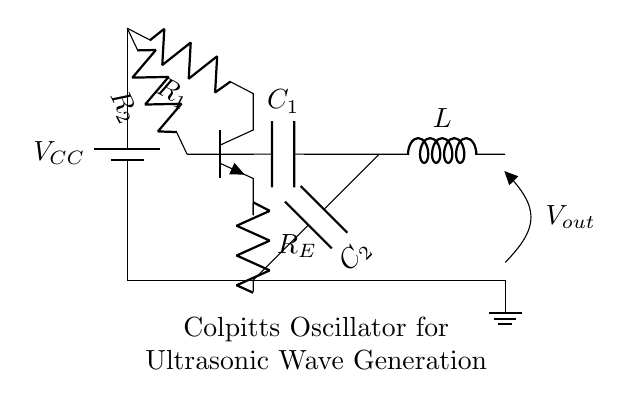What type of oscillator is depicted in the circuit? The circuit diagram specifically illustrates a Colpitts oscillator, which is characterized by its use of capacitors and inductors to form the feedback necessary for oscillation.
Answer: Colpitts oscillator What is the value of resistor R1? The circuit diagram does not specify the numerical values of component R1, but it is labeled to indicate its position and purpose within the circuit.
Answer: Not specified What components are used in this Colpitts oscillator? The essential components are a transistor, two capacitors (C1 and C2), an inductor (L), and three resistors (R1, R2, and RE), collectively facilitating oscillation.
Answer: Transistor, capacitors, inductor, resistors Where is the output voltage taken from in this circuit? The output voltage is taken across the inductor, as indicated by the notation placed at that point in the circuit (Vout). This is where the oscillation signal is outputted.
Answer: Across the inductor Why is the inductor used in the Colpitts oscillator? The inductor is key for generating oscillation in the Colpitts oscillator by resonating with the total capacitance formed by C1 and C2, setting the oscillation frequency. The combined effect of the inductor and capacitors allows for frequency selection in the circuit.
Answer: To generate oscillation frequency What role do capacitors C1 and C2 play in the circuit? Capacitors C1 and C2 create a capacitive voltage divider which is crucial in feedback, affecting the phase and amplitude of the signal to ensure stable oscillation. They determine the oscillation frequency in conjunction with the inductor.
Answer: Feedback and frequency determination 